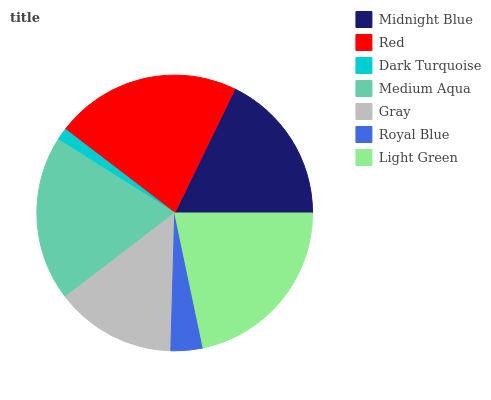Is Dark Turquoise the minimum?
Answer yes or no. Yes. Is Red the maximum?
Answer yes or no. Yes. Is Red the minimum?
Answer yes or no. No. Is Dark Turquoise the maximum?
Answer yes or no. No. Is Red greater than Dark Turquoise?
Answer yes or no. Yes. Is Dark Turquoise less than Red?
Answer yes or no. Yes. Is Dark Turquoise greater than Red?
Answer yes or no. No. Is Red less than Dark Turquoise?
Answer yes or no. No. Is Midnight Blue the high median?
Answer yes or no. Yes. Is Midnight Blue the low median?
Answer yes or no. Yes. Is Gray the high median?
Answer yes or no. No. Is Dark Turquoise the low median?
Answer yes or no. No. 